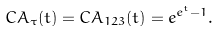<formula> <loc_0><loc_0><loc_500><loc_500>C A _ { \tau } ( t ) = C A _ { 1 2 3 } ( t ) = e ^ { e ^ { t } - 1 } .</formula> 